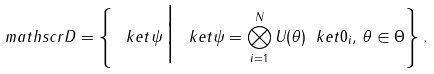<formula> <loc_0><loc_0><loc_500><loc_500>\ m a t h s c r { D } = \left \{ \, \ k e t { \psi } \, \Big | \, \ k e t { \psi } = \bigotimes _ { i = 1 } ^ { N } U ( \theta ) \ k e t { 0 } _ { i } , \, \theta \in \Theta \right \} .</formula> 